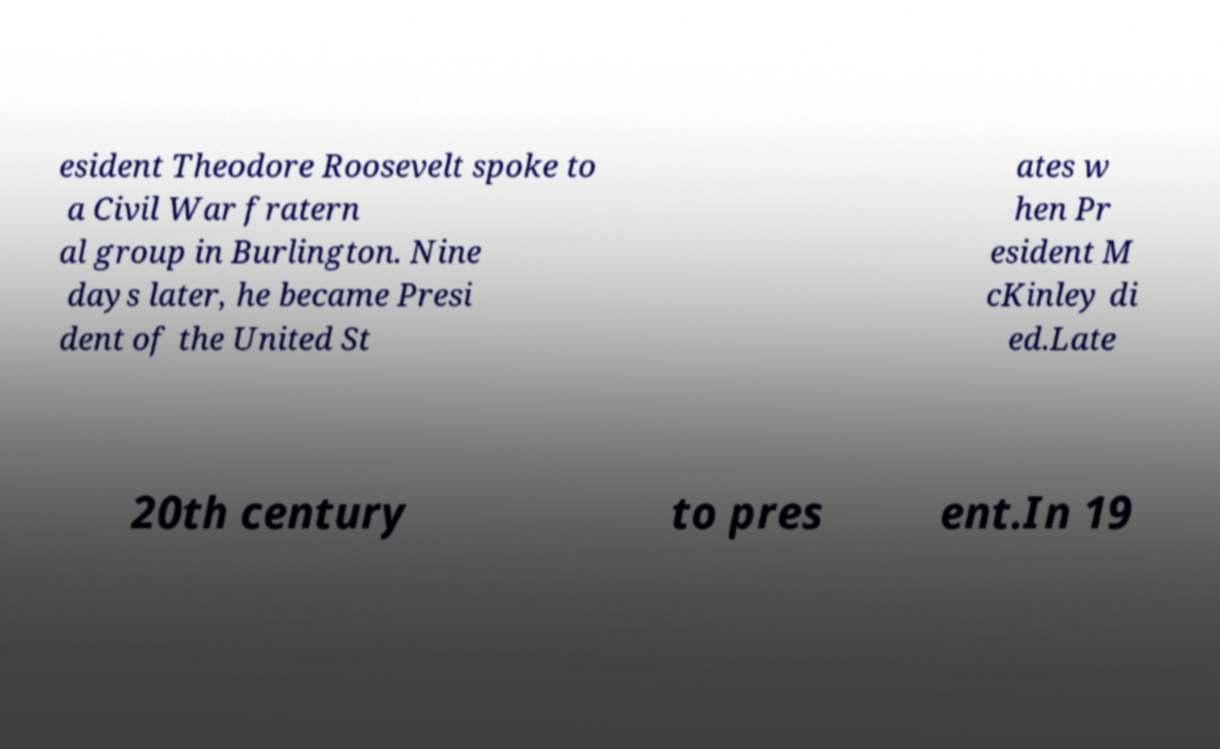There's text embedded in this image that I need extracted. Can you transcribe it verbatim? esident Theodore Roosevelt spoke to a Civil War fratern al group in Burlington. Nine days later, he became Presi dent of the United St ates w hen Pr esident M cKinley di ed.Late 20th century to pres ent.In 19 